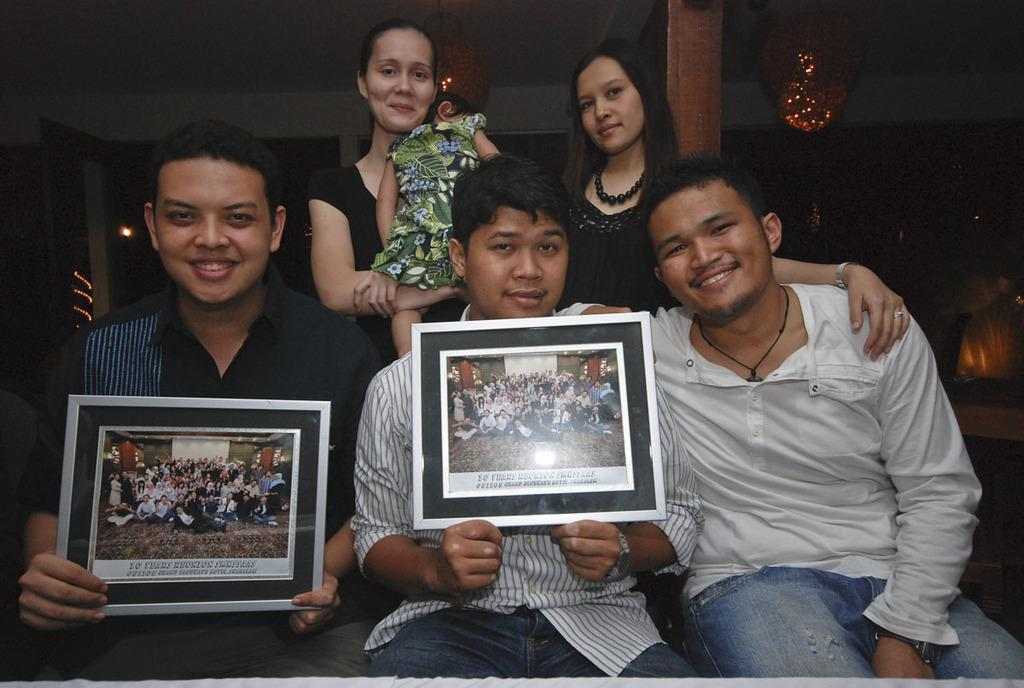How many people are in the picture? There are six members in the picture. Can you describe the composition of the group? There are men, women, and a child in the picture. What are two of the members holding in their hands? Two of the members are holding photo frames in their hands. What is the color of the background in the image? The background of the image is dark. What songs are being sung by the members in the picture? There is no indication in the image that the members are singing songs, so it cannot be determined from the picture. 